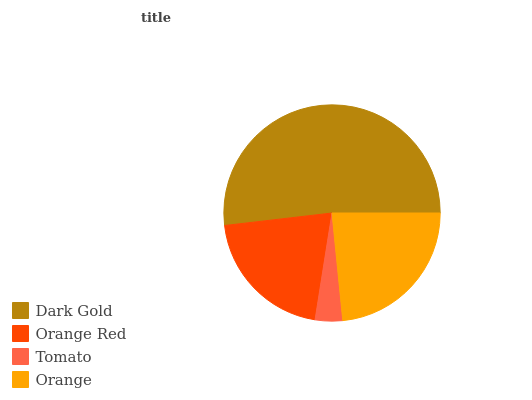Is Tomato the minimum?
Answer yes or no. Yes. Is Dark Gold the maximum?
Answer yes or no. Yes. Is Orange Red the minimum?
Answer yes or no. No. Is Orange Red the maximum?
Answer yes or no. No. Is Dark Gold greater than Orange Red?
Answer yes or no. Yes. Is Orange Red less than Dark Gold?
Answer yes or no. Yes. Is Orange Red greater than Dark Gold?
Answer yes or no. No. Is Dark Gold less than Orange Red?
Answer yes or no. No. Is Orange the high median?
Answer yes or no. Yes. Is Orange Red the low median?
Answer yes or no. Yes. Is Tomato the high median?
Answer yes or no. No. Is Tomato the low median?
Answer yes or no. No. 